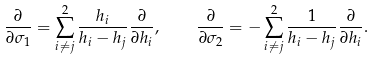Convert formula to latex. <formula><loc_0><loc_0><loc_500><loc_500>\frac { \partial } { \partial \sigma _ { 1 } } = \sum _ { i \neq j } ^ { 2 } \frac { h _ { i } } { h _ { i } - h _ { j } } \frac { \partial } { \partial h _ { i } } , \quad \frac { \partial } { \partial \sigma _ { 2 } } = - \sum _ { i \neq j } ^ { 2 } \frac { 1 } { h _ { i } - h _ { j } } \frac { \partial } { \partial h _ { i } } .</formula> 